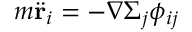Convert formula to latex. <formula><loc_0><loc_0><loc_500><loc_500>m \ddot { r } _ { i } = - \nabla \Sigma _ { j } \phi _ { i j }</formula> 